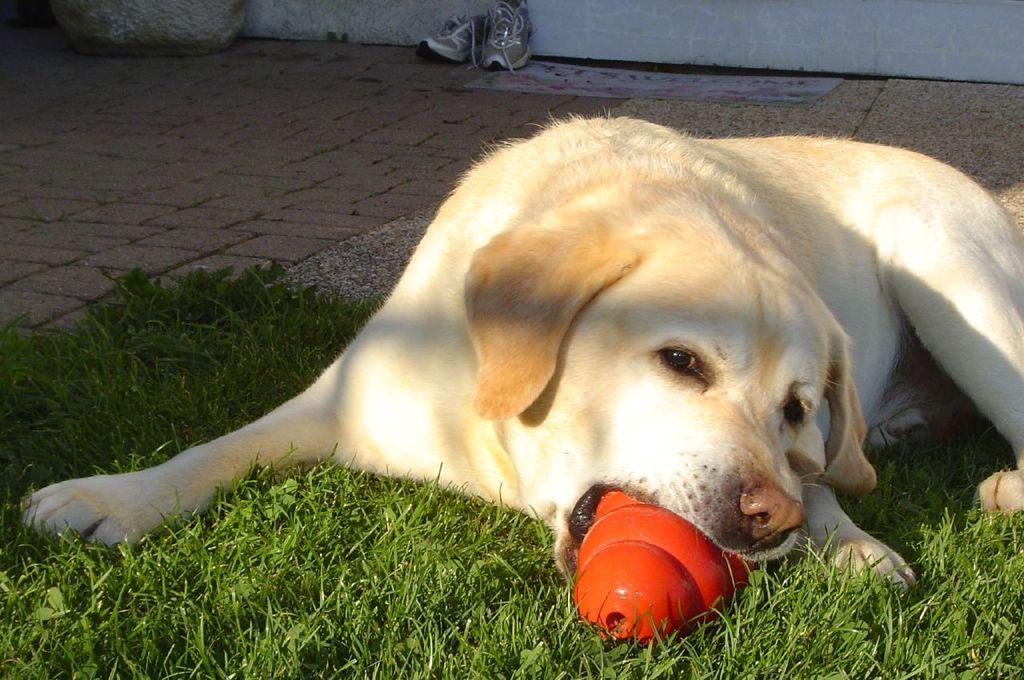Please provide a concise description of this image. In this image, we can see a dog with an object in its mouth. We can see the ground with some objects like a pair of shoes. We can see some grass and the wall. 